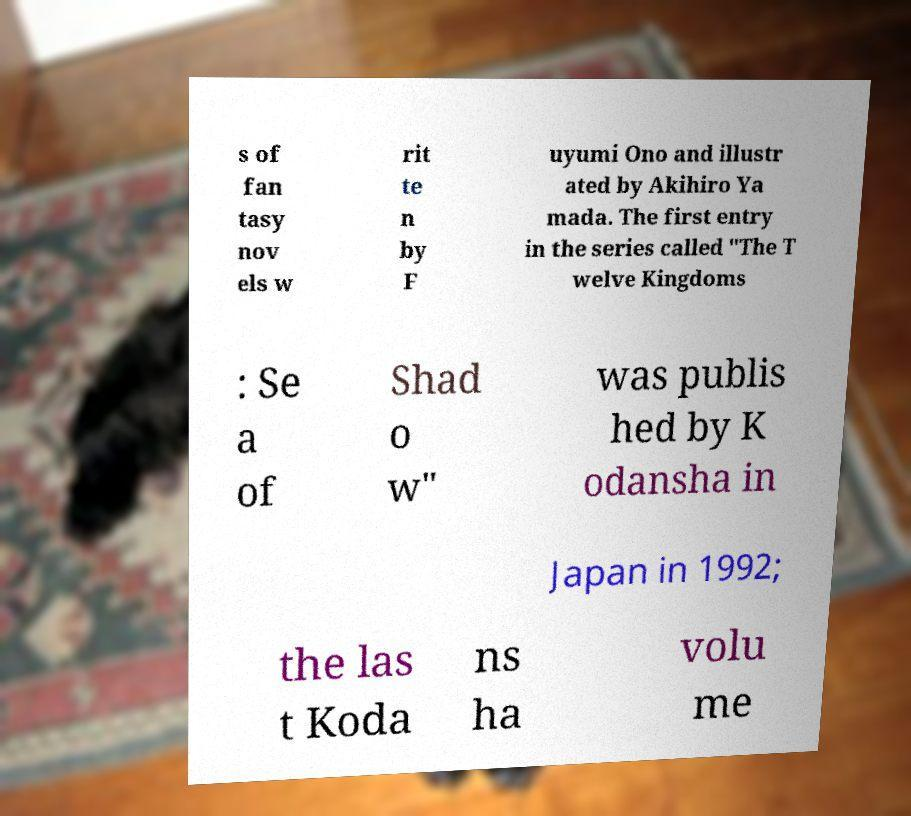Please read and relay the text visible in this image. What does it say? s of fan tasy nov els w rit te n by F uyumi Ono and illustr ated by Akihiro Ya mada. The first entry in the series called "The T welve Kingdoms : Se a of Shad o w" was publis hed by K odansha in Japan in 1992; the las t Koda ns ha volu me 